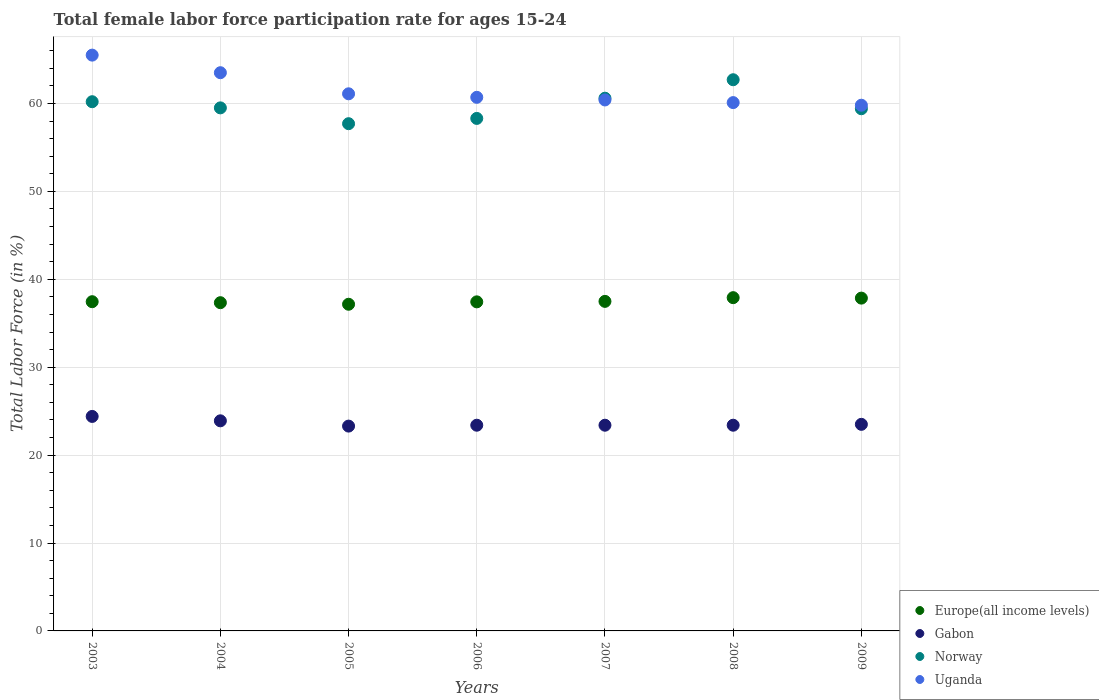How many different coloured dotlines are there?
Make the answer very short. 4. Is the number of dotlines equal to the number of legend labels?
Offer a terse response. Yes. What is the female labor force participation rate in Uganda in 2005?
Offer a terse response. 61.1. Across all years, what is the maximum female labor force participation rate in Europe(all income levels)?
Provide a succinct answer. 37.91. Across all years, what is the minimum female labor force participation rate in Europe(all income levels)?
Offer a very short reply. 37.16. In which year was the female labor force participation rate in Norway maximum?
Give a very brief answer. 2008. In which year was the female labor force participation rate in Europe(all income levels) minimum?
Offer a very short reply. 2005. What is the total female labor force participation rate in Europe(all income levels) in the graph?
Offer a terse response. 262.64. What is the difference between the female labor force participation rate in Gabon in 2005 and that in 2007?
Provide a short and direct response. -0.1. What is the difference between the female labor force participation rate in Norway in 2008 and the female labor force participation rate in Uganda in 2009?
Offer a terse response. 2.9. What is the average female labor force participation rate in Norway per year?
Offer a terse response. 59.77. In the year 2009, what is the difference between the female labor force participation rate in Norway and female labor force participation rate in Gabon?
Give a very brief answer. 35.9. What is the ratio of the female labor force participation rate in Gabon in 2003 to that in 2008?
Your answer should be compact. 1.04. Is the difference between the female labor force participation rate in Norway in 2006 and 2009 greater than the difference between the female labor force participation rate in Gabon in 2006 and 2009?
Your answer should be very brief. No. What is the difference between the highest and the lowest female labor force participation rate in Europe(all income levels)?
Your answer should be compact. 0.75. Is it the case that in every year, the sum of the female labor force participation rate in Europe(all income levels) and female labor force participation rate in Gabon  is greater than the sum of female labor force participation rate in Norway and female labor force participation rate in Uganda?
Provide a short and direct response. Yes. Is it the case that in every year, the sum of the female labor force participation rate in Norway and female labor force participation rate in Uganda  is greater than the female labor force participation rate in Europe(all income levels)?
Provide a short and direct response. Yes. Does the female labor force participation rate in Gabon monotonically increase over the years?
Provide a short and direct response. No. Is the female labor force participation rate in Gabon strictly greater than the female labor force participation rate in Uganda over the years?
Provide a succinct answer. No. Is the female labor force participation rate in Uganda strictly less than the female labor force participation rate in Norway over the years?
Your answer should be very brief. No. How many years are there in the graph?
Make the answer very short. 7. What is the difference between two consecutive major ticks on the Y-axis?
Offer a terse response. 10. Are the values on the major ticks of Y-axis written in scientific E-notation?
Offer a terse response. No. Does the graph contain any zero values?
Give a very brief answer. No. How many legend labels are there?
Your answer should be very brief. 4. What is the title of the graph?
Provide a short and direct response. Total female labor force participation rate for ages 15-24. What is the Total Labor Force (in %) in Europe(all income levels) in 2003?
Offer a very short reply. 37.45. What is the Total Labor Force (in %) of Gabon in 2003?
Your answer should be very brief. 24.4. What is the Total Labor Force (in %) of Norway in 2003?
Keep it short and to the point. 60.2. What is the Total Labor Force (in %) of Uganda in 2003?
Provide a short and direct response. 65.5. What is the Total Labor Force (in %) in Europe(all income levels) in 2004?
Offer a terse response. 37.34. What is the Total Labor Force (in %) in Gabon in 2004?
Keep it short and to the point. 23.9. What is the Total Labor Force (in %) in Norway in 2004?
Make the answer very short. 59.5. What is the Total Labor Force (in %) in Uganda in 2004?
Your answer should be compact. 63.5. What is the Total Labor Force (in %) in Europe(all income levels) in 2005?
Provide a succinct answer. 37.16. What is the Total Labor Force (in %) of Gabon in 2005?
Your response must be concise. 23.3. What is the Total Labor Force (in %) in Norway in 2005?
Ensure brevity in your answer.  57.7. What is the Total Labor Force (in %) of Uganda in 2005?
Your response must be concise. 61.1. What is the Total Labor Force (in %) in Europe(all income levels) in 2006?
Your answer should be very brief. 37.43. What is the Total Labor Force (in %) in Gabon in 2006?
Make the answer very short. 23.4. What is the Total Labor Force (in %) of Norway in 2006?
Keep it short and to the point. 58.3. What is the Total Labor Force (in %) of Uganda in 2006?
Keep it short and to the point. 60.7. What is the Total Labor Force (in %) of Europe(all income levels) in 2007?
Provide a short and direct response. 37.49. What is the Total Labor Force (in %) of Gabon in 2007?
Make the answer very short. 23.4. What is the Total Labor Force (in %) in Norway in 2007?
Your answer should be very brief. 60.6. What is the Total Labor Force (in %) of Uganda in 2007?
Provide a short and direct response. 60.4. What is the Total Labor Force (in %) of Europe(all income levels) in 2008?
Make the answer very short. 37.91. What is the Total Labor Force (in %) in Gabon in 2008?
Your response must be concise. 23.4. What is the Total Labor Force (in %) of Norway in 2008?
Provide a succinct answer. 62.7. What is the Total Labor Force (in %) in Uganda in 2008?
Your answer should be compact. 60.1. What is the Total Labor Force (in %) of Europe(all income levels) in 2009?
Ensure brevity in your answer.  37.86. What is the Total Labor Force (in %) of Norway in 2009?
Your answer should be compact. 59.4. What is the Total Labor Force (in %) in Uganda in 2009?
Make the answer very short. 59.8. Across all years, what is the maximum Total Labor Force (in %) in Europe(all income levels)?
Provide a short and direct response. 37.91. Across all years, what is the maximum Total Labor Force (in %) of Gabon?
Your answer should be compact. 24.4. Across all years, what is the maximum Total Labor Force (in %) of Norway?
Your answer should be very brief. 62.7. Across all years, what is the maximum Total Labor Force (in %) in Uganda?
Your response must be concise. 65.5. Across all years, what is the minimum Total Labor Force (in %) in Europe(all income levels)?
Ensure brevity in your answer.  37.16. Across all years, what is the minimum Total Labor Force (in %) of Gabon?
Offer a very short reply. 23.3. Across all years, what is the minimum Total Labor Force (in %) of Norway?
Give a very brief answer. 57.7. Across all years, what is the minimum Total Labor Force (in %) in Uganda?
Keep it short and to the point. 59.8. What is the total Total Labor Force (in %) of Europe(all income levels) in the graph?
Offer a terse response. 262.64. What is the total Total Labor Force (in %) of Gabon in the graph?
Provide a short and direct response. 165.3. What is the total Total Labor Force (in %) of Norway in the graph?
Provide a succinct answer. 418.4. What is the total Total Labor Force (in %) of Uganda in the graph?
Provide a succinct answer. 431.1. What is the difference between the Total Labor Force (in %) of Europe(all income levels) in 2003 and that in 2004?
Your answer should be very brief. 0.11. What is the difference between the Total Labor Force (in %) in Gabon in 2003 and that in 2004?
Ensure brevity in your answer.  0.5. What is the difference between the Total Labor Force (in %) in Uganda in 2003 and that in 2004?
Provide a succinct answer. 2. What is the difference between the Total Labor Force (in %) in Europe(all income levels) in 2003 and that in 2005?
Your answer should be compact. 0.29. What is the difference between the Total Labor Force (in %) of Norway in 2003 and that in 2005?
Provide a succinct answer. 2.5. What is the difference between the Total Labor Force (in %) of Europe(all income levels) in 2003 and that in 2006?
Your answer should be compact. 0.02. What is the difference between the Total Labor Force (in %) in Gabon in 2003 and that in 2006?
Offer a very short reply. 1. What is the difference between the Total Labor Force (in %) of Uganda in 2003 and that in 2006?
Your answer should be compact. 4.8. What is the difference between the Total Labor Force (in %) of Europe(all income levels) in 2003 and that in 2007?
Keep it short and to the point. -0.04. What is the difference between the Total Labor Force (in %) of Gabon in 2003 and that in 2007?
Offer a terse response. 1. What is the difference between the Total Labor Force (in %) in Norway in 2003 and that in 2007?
Make the answer very short. -0.4. What is the difference between the Total Labor Force (in %) in Uganda in 2003 and that in 2007?
Offer a terse response. 5.1. What is the difference between the Total Labor Force (in %) of Europe(all income levels) in 2003 and that in 2008?
Offer a very short reply. -0.46. What is the difference between the Total Labor Force (in %) in Europe(all income levels) in 2003 and that in 2009?
Keep it short and to the point. -0.41. What is the difference between the Total Labor Force (in %) of Europe(all income levels) in 2004 and that in 2005?
Make the answer very short. 0.18. What is the difference between the Total Labor Force (in %) of Uganda in 2004 and that in 2005?
Provide a succinct answer. 2.4. What is the difference between the Total Labor Force (in %) in Europe(all income levels) in 2004 and that in 2006?
Offer a terse response. -0.09. What is the difference between the Total Labor Force (in %) of Europe(all income levels) in 2004 and that in 2007?
Provide a succinct answer. -0.15. What is the difference between the Total Labor Force (in %) of Europe(all income levels) in 2004 and that in 2008?
Ensure brevity in your answer.  -0.57. What is the difference between the Total Labor Force (in %) in Gabon in 2004 and that in 2008?
Your answer should be compact. 0.5. What is the difference between the Total Labor Force (in %) of Norway in 2004 and that in 2008?
Your response must be concise. -3.2. What is the difference between the Total Labor Force (in %) of Uganda in 2004 and that in 2008?
Offer a terse response. 3.4. What is the difference between the Total Labor Force (in %) of Europe(all income levels) in 2004 and that in 2009?
Offer a terse response. -0.52. What is the difference between the Total Labor Force (in %) of Norway in 2004 and that in 2009?
Keep it short and to the point. 0.1. What is the difference between the Total Labor Force (in %) of Europe(all income levels) in 2005 and that in 2006?
Offer a terse response. -0.27. What is the difference between the Total Labor Force (in %) of Norway in 2005 and that in 2006?
Ensure brevity in your answer.  -0.6. What is the difference between the Total Labor Force (in %) of Uganda in 2005 and that in 2006?
Make the answer very short. 0.4. What is the difference between the Total Labor Force (in %) in Europe(all income levels) in 2005 and that in 2007?
Give a very brief answer. -0.33. What is the difference between the Total Labor Force (in %) of Norway in 2005 and that in 2007?
Make the answer very short. -2.9. What is the difference between the Total Labor Force (in %) of Uganda in 2005 and that in 2007?
Offer a very short reply. 0.7. What is the difference between the Total Labor Force (in %) of Europe(all income levels) in 2005 and that in 2008?
Provide a succinct answer. -0.75. What is the difference between the Total Labor Force (in %) of Gabon in 2005 and that in 2008?
Make the answer very short. -0.1. What is the difference between the Total Labor Force (in %) in Uganda in 2005 and that in 2008?
Offer a terse response. 1. What is the difference between the Total Labor Force (in %) of Europe(all income levels) in 2005 and that in 2009?
Make the answer very short. -0.7. What is the difference between the Total Labor Force (in %) in Norway in 2005 and that in 2009?
Provide a short and direct response. -1.7. What is the difference between the Total Labor Force (in %) in Europe(all income levels) in 2006 and that in 2007?
Make the answer very short. -0.05. What is the difference between the Total Labor Force (in %) in Gabon in 2006 and that in 2007?
Offer a terse response. 0. What is the difference between the Total Labor Force (in %) of Norway in 2006 and that in 2007?
Give a very brief answer. -2.3. What is the difference between the Total Labor Force (in %) in Europe(all income levels) in 2006 and that in 2008?
Make the answer very short. -0.48. What is the difference between the Total Labor Force (in %) of Norway in 2006 and that in 2008?
Provide a succinct answer. -4.4. What is the difference between the Total Labor Force (in %) of Europe(all income levels) in 2006 and that in 2009?
Offer a very short reply. -0.43. What is the difference between the Total Labor Force (in %) of Gabon in 2006 and that in 2009?
Ensure brevity in your answer.  -0.1. What is the difference between the Total Labor Force (in %) of Europe(all income levels) in 2007 and that in 2008?
Keep it short and to the point. -0.42. What is the difference between the Total Labor Force (in %) in Uganda in 2007 and that in 2008?
Offer a very short reply. 0.3. What is the difference between the Total Labor Force (in %) of Europe(all income levels) in 2007 and that in 2009?
Your answer should be compact. -0.37. What is the difference between the Total Labor Force (in %) of Gabon in 2007 and that in 2009?
Provide a succinct answer. -0.1. What is the difference between the Total Labor Force (in %) of Norway in 2007 and that in 2009?
Give a very brief answer. 1.2. What is the difference between the Total Labor Force (in %) in Europe(all income levels) in 2008 and that in 2009?
Your answer should be compact. 0.05. What is the difference between the Total Labor Force (in %) in Norway in 2008 and that in 2009?
Make the answer very short. 3.3. What is the difference between the Total Labor Force (in %) of Uganda in 2008 and that in 2009?
Your response must be concise. 0.3. What is the difference between the Total Labor Force (in %) in Europe(all income levels) in 2003 and the Total Labor Force (in %) in Gabon in 2004?
Offer a terse response. 13.55. What is the difference between the Total Labor Force (in %) in Europe(all income levels) in 2003 and the Total Labor Force (in %) in Norway in 2004?
Make the answer very short. -22.05. What is the difference between the Total Labor Force (in %) in Europe(all income levels) in 2003 and the Total Labor Force (in %) in Uganda in 2004?
Provide a short and direct response. -26.05. What is the difference between the Total Labor Force (in %) of Gabon in 2003 and the Total Labor Force (in %) of Norway in 2004?
Keep it short and to the point. -35.1. What is the difference between the Total Labor Force (in %) in Gabon in 2003 and the Total Labor Force (in %) in Uganda in 2004?
Offer a terse response. -39.1. What is the difference between the Total Labor Force (in %) in Norway in 2003 and the Total Labor Force (in %) in Uganda in 2004?
Provide a succinct answer. -3.3. What is the difference between the Total Labor Force (in %) of Europe(all income levels) in 2003 and the Total Labor Force (in %) of Gabon in 2005?
Provide a short and direct response. 14.15. What is the difference between the Total Labor Force (in %) in Europe(all income levels) in 2003 and the Total Labor Force (in %) in Norway in 2005?
Your answer should be compact. -20.25. What is the difference between the Total Labor Force (in %) of Europe(all income levels) in 2003 and the Total Labor Force (in %) of Uganda in 2005?
Offer a terse response. -23.65. What is the difference between the Total Labor Force (in %) in Gabon in 2003 and the Total Labor Force (in %) in Norway in 2005?
Provide a succinct answer. -33.3. What is the difference between the Total Labor Force (in %) in Gabon in 2003 and the Total Labor Force (in %) in Uganda in 2005?
Offer a terse response. -36.7. What is the difference between the Total Labor Force (in %) in Europe(all income levels) in 2003 and the Total Labor Force (in %) in Gabon in 2006?
Offer a very short reply. 14.05. What is the difference between the Total Labor Force (in %) of Europe(all income levels) in 2003 and the Total Labor Force (in %) of Norway in 2006?
Provide a short and direct response. -20.85. What is the difference between the Total Labor Force (in %) in Europe(all income levels) in 2003 and the Total Labor Force (in %) in Uganda in 2006?
Provide a succinct answer. -23.25. What is the difference between the Total Labor Force (in %) in Gabon in 2003 and the Total Labor Force (in %) in Norway in 2006?
Ensure brevity in your answer.  -33.9. What is the difference between the Total Labor Force (in %) of Gabon in 2003 and the Total Labor Force (in %) of Uganda in 2006?
Your response must be concise. -36.3. What is the difference between the Total Labor Force (in %) of Norway in 2003 and the Total Labor Force (in %) of Uganda in 2006?
Your answer should be very brief. -0.5. What is the difference between the Total Labor Force (in %) of Europe(all income levels) in 2003 and the Total Labor Force (in %) of Gabon in 2007?
Ensure brevity in your answer.  14.05. What is the difference between the Total Labor Force (in %) of Europe(all income levels) in 2003 and the Total Labor Force (in %) of Norway in 2007?
Offer a terse response. -23.15. What is the difference between the Total Labor Force (in %) in Europe(all income levels) in 2003 and the Total Labor Force (in %) in Uganda in 2007?
Offer a terse response. -22.95. What is the difference between the Total Labor Force (in %) of Gabon in 2003 and the Total Labor Force (in %) of Norway in 2007?
Make the answer very short. -36.2. What is the difference between the Total Labor Force (in %) in Gabon in 2003 and the Total Labor Force (in %) in Uganda in 2007?
Your answer should be compact. -36. What is the difference between the Total Labor Force (in %) of Europe(all income levels) in 2003 and the Total Labor Force (in %) of Gabon in 2008?
Provide a succinct answer. 14.05. What is the difference between the Total Labor Force (in %) in Europe(all income levels) in 2003 and the Total Labor Force (in %) in Norway in 2008?
Your answer should be compact. -25.25. What is the difference between the Total Labor Force (in %) in Europe(all income levels) in 2003 and the Total Labor Force (in %) in Uganda in 2008?
Your answer should be very brief. -22.65. What is the difference between the Total Labor Force (in %) in Gabon in 2003 and the Total Labor Force (in %) in Norway in 2008?
Provide a succinct answer. -38.3. What is the difference between the Total Labor Force (in %) in Gabon in 2003 and the Total Labor Force (in %) in Uganda in 2008?
Provide a short and direct response. -35.7. What is the difference between the Total Labor Force (in %) in Europe(all income levels) in 2003 and the Total Labor Force (in %) in Gabon in 2009?
Provide a succinct answer. 13.95. What is the difference between the Total Labor Force (in %) of Europe(all income levels) in 2003 and the Total Labor Force (in %) of Norway in 2009?
Ensure brevity in your answer.  -21.95. What is the difference between the Total Labor Force (in %) of Europe(all income levels) in 2003 and the Total Labor Force (in %) of Uganda in 2009?
Offer a terse response. -22.35. What is the difference between the Total Labor Force (in %) in Gabon in 2003 and the Total Labor Force (in %) in Norway in 2009?
Your answer should be compact. -35. What is the difference between the Total Labor Force (in %) in Gabon in 2003 and the Total Labor Force (in %) in Uganda in 2009?
Provide a short and direct response. -35.4. What is the difference between the Total Labor Force (in %) in Norway in 2003 and the Total Labor Force (in %) in Uganda in 2009?
Offer a very short reply. 0.4. What is the difference between the Total Labor Force (in %) of Europe(all income levels) in 2004 and the Total Labor Force (in %) of Gabon in 2005?
Your answer should be compact. 14.04. What is the difference between the Total Labor Force (in %) in Europe(all income levels) in 2004 and the Total Labor Force (in %) in Norway in 2005?
Offer a terse response. -20.36. What is the difference between the Total Labor Force (in %) of Europe(all income levels) in 2004 and the Total Labor Force (in %) of Uganda in 2005?
Ensure brevity in your answer.  -23.76. What is the difference between the Total Labor Force (in %) of Gabon in 2004 and the Total Labor Force (in %) of Norway in 2005?
Your answer should be compact. -33.8. What is the difference between the Total Labor Force (in %) in Gabon in 2004 and the Total Labor Force (in %) in Uganda in 2005?
Offer a terse response. -37.2. What is the difference between the Total Labor Force (in %) of Norway in 2004 and the Total Labor Force (in %) of Uganda in 2005?
Your answer should be very brief. -1.6. What is the difference between the Total Labor Force (in %) in Europe(all income levels) in 2004 and the Total Labor Force (in %) in Gabon in 2006?
Offer a very short reply. 13.94. What is the difference between the Total Labor Force (in %) of Europe(all income levels) in 2004 and the Total Labor Force (in %) of Norway in 2006?
Offer a very short reply. -20.96. What is the difference between the Total Labor Force (in %) in Europe(all income levels) in 2004 and the Total Labor Force (in %) in Uganda in 2006?
Your response must be concise. -23.36. What is the difference between the Total Labor Force (in %) of Gabon in 2004 and the Total Labor Force (in %) of Norway in 2006?
Provide a short and direct response. -34.4. What is the difference between the Total Labor Force (in %) of Gabon in 2004 and the Total Labor Force (in %) of Uganda in 2006?
Your answer should be compact. -36.8. What is the difference between the Total Labor Force (in %) in Europe(all income levels) in 2004 and the Total Labor Force (in %) in Gabon in 2007?
Offer a terse response. 13.94. What is the difference between the Total Labor Force (in %) of Europe(all income levels) in 2004 and the Total Labor Force (in %) of Norway in 2007?
Provide a succinct answer. -23.26. What is the difference between the Total Labor Force (in %) of Europe(all income levels) in 2004 and the Total Labor Force (in %) of Uganda in 2007?
Provide a short and direct response. -23.06. What is the difference between the Total Labor Force (in %) in Gabon in 2004 and the Total Labor Force (in %) in Norway in 2007?
Keep it short and to the point. -36.7. What is the difference between the Total Labor Force (in %) in Gabon in 2004 and the Total Labor Force (in %) in Uganda in 2007?
Your answer should be very brief. -36.5. What is the difference between the Total Labor Force (in %) of Europe(all income levels) in 2004 and the Total Labor Force (in %) of Gabon in 2008?
Offer a very short reply. 13.94. What is the difference between the Total Labor Force (in %) in Europe(all income levels) in 2004 and the Total Labor Force (in %) in Norway in 2008?
Give a very brief answer. -25.36. What is the difference between the Total Labor Force (in %) in Europe(all income levels) in 2004 and the Total Labor Force (in %) in Uganda in 2008?
Your response must be concise. -22.76. What is the difference between the Total Labor Force (in %) in Gabon in 2004 and the Total Labor Force (in %) in Norway in 2008?
Your answer should be compact. -38.8. What is the difference between the Total Labor Force (in %) of Gabon in 2004 and the Total Labor Force (in %) of Uganda in 2008?
Keep it short and to the point. -36.2. What is the difference between the Total Labor Force (in %) in Norway in 2004 and the Total Labor Force (in %) in Uganda in 2008?
Keep it short and to the point. -0.6. What is the difference between the Total Labor Force (in %) of Europe(all income levels) in 2004 and the Total Labor Force (in %) of Gabon in 2009?
Ensure brevity in your answer.  13.84. What is the difference between the Total Labor Force (in %) of Europe(all income levels) in 2004 and the Total Labor Force (in %) of Norway in 2009?
Offer a very short reply. -22.06. What is the difference between the Total Labor Force (in %) of Europe(all income levels) in 2004 and the Total Labor Force (in %) of Uganda in 2009?
Offer a very short reply. -22.46. What is the difference between the Total Labor Force (in %) in Gabon in 2004 and the Total Labor Force (in %) in Norway in 2009?
Offer a very short reply. -35.5. What is the difference between the Total Labor Force (in %) in Gabon in 2004 and the Total Labor Force (in %) in Uganda in 2009?
Give a very brief answer. -35.9. What is the difference between the Total Labor Force (in %) of Norway in 2004 and the Total Labor Force (in %) of Uganda in 2009?
Provide a succinct answer. -0.3. What is the difference between the Total Labor Force (in %) of Europe(all income levels) in 2005 and the Total Labor Force (in %) of Gabon in 2006?
Offer a very short reply. 13.76. What is the difference between the Total Labor Force (in %) of Europe(all income levels) in 2005 and the Total Labor Force (in %) of Norway in 2006?
Make the answer very short. -21.14. What is the difference between the Total Labor Force (in %) in Europe(all income levels) in 2005 and the Total Labor Force (in %) in Uganda in 2006?
Keep it short and to the point. -23.54. What is the difference between the Total Labor Force (in %) of Gabon in 2005 and the Total Labor Force (in %) of Norway in 2006?
Provide a succinct answer. -35. What is the difference between the Total Labor Force (in %) in Gabon in 2005 and the Total Labor Force (in %) in Uganda in 2006?
Offer a terse response. -37.4. What is the difference between the Total Labor Force (in %) of Europe(all income levels) in 2005 and the Total Labor Force (in %) of Gabon in 2007?
Provide a short and direct response. 13.76. What is the difference between the Total Labor Force (in %) of Europe(all income levels) in 2005 and the Total Labor Force (in %) of Norway in 2007?
Your response must be concise. -23.44. What is the difference between the Total Labor Force (in %) of Europe(all income levels) in 2005 and the Total Labor Force (in %) of Uganda in 2007?
Make the answer very short. -23.24. What is the difference between the Total Labor Force (in %) of Gabon in 2005 and the Total Labor Force (in %) of Norway in 2007?
Provide a short and direct response. -37.3. What is the difference between the Total Labor Force (in %) of Gabon in 2005 and the Total Labor Force (in %) of Uganda in 2007?
Ensure brevity in your answer.  -37.1. What is the difference between the Total Labor Force (in %) of Europe(all income levels) in 2005 and the Total Labor Force (in %) of Gabon in 2008?
Your response must be concise. 13.76. What is the difference between the Total Labor Force (in %) of Europe(all income levels) in 2005 and the Total Labor Force (in %) of Norway in 2008?
Give a very brief answer. -25.54. What is the difference between the Total Labor Force (in %) of Europe(all income levels) in 2005 and the Total Labor Force (in %) of Uganda in 2008?
Make the answer very short. -22.94. What is the difference between the Total Labor Force (in %) in Gabon in 2005 and the Total Labor Force (in %) in Norway in 2008?
Your answer should be compact. -39.4. What is the difference between the Total Labor Force (in %) in Gabon in 2005 and the Total Labor Force (in %) in Uganda in 2008?
Provide a succinct answer. -36.8. What is the difference between the Total Labor Force (in %) of Europe(all income levels) in 2005 and the Total Labor Force (in %) of Gabon in 2009?
Your answer should be compact. 13.66. What is the difference between the Total Labor Force (in %) of Europe(all income levels) in 2005 and the Total Labor Force (in %) of Norway in 2009?
Give a very brief answer. -22.24. What is the difference between the Total Labor Force (in %) of Europe(all income levels) in 2005 and the Total Labor Force (in %) of Uganda in 2009?
Provide a succinct answer. -22.64. What is the difference between the Total Labor Force (in %) in Gabon in 2005 and the Total Labor Force (in %) in Norway in 2009?
Give a very brief answer. -36.1. What is the difference between the Total Labor Force (in %) in Gabon in 2005 and the Total Labor Force (in %) in Uganda in 2009?
Ensure brevity in your answer.  -36.5. What is the difference between the Total Labor Force (in %) of Norway in 2005 and the Total Labor Force (in %) of Uganda in 2009?
Make the answer very short. -2.1. What is the difference between the Total Labor Force (in %) in Europe(all income levels) in 2006 and the Total Labor Force (in %) in Gabon in 2007?
Offer a terse response. 14.03. What is the difference between the Total Labor Force (in %) in Europe(all income levels) in 2006 and the Total Labor Force (in %) in Norway in 2007?
Provide a succinct answer. -23.17. What is the difference between the Total Labor Force (in %) in Europe(all income levels) in 2006 and the Total Labor Force (in %) in Uganda in 2007?
Make the answer very short. -22.97. What is the difference between the Total Labor Force (in %) of Gabon in 2006 and the Total Labor Force (in %) of Norway in 2007?
Give a very brief answer. -37.2. What is the difference between the Total Labor Force (in %) of Gabon in 2006 and the Total Labor Force (in %) of Uganda in 2007?
Keep it short and to the point. -37. What is the difference between the Total Labor Force (in %) of Norway in 2006 and the Total Labor Force (in %) of Uganda in 2007?
Offer a very short reply. -2.1. What is the difference between the Total Labor Force (in %) of Europe(all income levels) in 2006 and the Total Labor Force (in %) of Gabon in 2008?
Offer a very short reply. 14.03. What is the difference between the Total Labor Force (in %) of Europe(all income levels) in 2006 and the Total Labor Force (in %) of Norway in 2008?
Keep it short and to the point. -25.27. What is the difference between the Total Labor Force (in %) in Europe(all income levels) in 2006 and the Total Labor Force (in %) in Uganda in 2008?
Offer a terse response. -22.67. What is the difference between the Total Labor Force (in %) of Gabon in 2006 and the Total Labor Force (in %) of Norway in 2008?
Ensure brevity in your answer.  -39.3. What is the difference between the Total Labor Force (in %) in Gabon in 2006 and the Total Labor Force (in %) in Uganda in 2008?
Ensure brevity in your answer.  -36.7. What is the difference between the Total Labor Force (in %) of Norway in 2006 and the Total Labor Force (in %) of Uganda in 2008?
Your response must be concise. -1.8. What is the difference between the Total Labor Force (in %) of Europe(all income levels) in 2006 and the Total Labor Force (in %) of Gabon in 2009?
Make the answer very short. 13.93. What is the difference between the Total Labor Force (in %) in Europe(all income levels) in 2006 and the Total Labor Force (in %) in Norway in 2009?
Give a very brief answer. -21.97. What is the difference between the Total Labor Force (in %) of Europe(all income levels) in 2006 and the Total Labor Force (in %) of Uganda in 2009?
Ensure brevity in your answer.  -22.37. What is the difference between the Total Labor Force (in %) in Gabon in 2006 and the Total Labor Force (in %) in Norway in 2009?
Provide a succinct answer. -36. What is the difference between the Total Labor Force (in %) of Gabon in 2006 and the Total Labor Force (in %) of Uganda in 2009?
Make the answer very short. -36.4. What is the difference between the Total Labor Force (in %) in Europe(all income levels) in 2007 and the Total Labor Force (in %) in Gabon in 2008?
Give a very brief answer. 14.09. What is the difference between the Total Labor Force (in %) of Europe(all income levels) in 2007 and the Total Labor Force (in %) of Norway in 2008?
Provide a succinct answer. -25.21. What is the difference between the Total Labor Force (in %) of Europe(all income levels) in 2007 and the Total Labor Force (in %) of Uganda in 2008?
Provide a short and direct response. -22.61. What is the difference between the Total Labor Force (in %) of Gabon in 2007 and the Total Labor Force (in %) of Norway in 2008?
Offer a terse response. -39.3. What is the difference between the Total Labor Force (in %) in Gabon in 2007 and the Total Labor Force (in %) in Uganda in 2008?
Provide a succinct answer. -36.7. What is the difference between the Total Labor Force (in %) in Europe(all income levels) in 2007 and the Total Labor Force (in %) in Gabon in 2009?
Offer a terse response. 13.99. What is the difference between the Total Labor Force (in %) in Europe(all income levels) in 2007 and the Total Labor Force (in %) in Norway in 2009?
Provide a succinct answer. -21.91. What is the difference between the Total Labor Force (in %) in Europe(all income levels) in 2007 and the Total Labor Force (in %) in Uganda in 2009?
Offer a very short reply. -22.31. What is the difference between the Total Labor Force (in %) in Gabon in 2007 and the Total Labor Force (in %) in Norway in 2009?
Provide a succinct answer. -36. What is the difference between the Total Labor Force (in %) in Gabon in 2007 and the Total Labor Force (in %) in Uganda in 2009?
Offer a very short reply. -36.4. What is the difference between the Total Labor Force (in %) of Norway in 2007 and the Total Labor Force (in %) of Uganda in 2009?
Make the answer very short. 0.8. What is the difference between the Total Labor Force (in %) in Europe(all income levels) in 2008 and the Total Labor Force (in %) in Gabon in 2009?
Offer a very short reply. 14.41. What is the difference between the Total Labor Force (in %) in Europe(all income levels) in 2008 and the Total Labor Force (in %) in Norway in 2009?
Make the answer very short. -21.49. What is the difference between the Total Labor Force (in %) in Europe(all income levels) in 2008 and the Total Labor Force (in %) in Uganda in 2009?
Your answer should be very brief. -21.89. What is the difference between the Total Labor Force (in %) in Gabon in 2008 and the Total Labor Force (in %) in Norway in 2009?
Offer a very short reply. -36. What is the difference between the Total Labor Force (in %) of Gabon in 2008 and the Total Labor Force (in %) of Uganda in 2009?
Provide a short and direct response. -36.4. What is the difference between the Total Labor Force (in %) in Norway in 2008 and the Total Labor Force (in %) in Uganda in 2009?
Make the answer very short. 2.9. What is the average Total Labor Force (in %) of Europe(all income levels) per year?
Make the answer very short. 37.52. What is the average Total Labor Force (in %) of Gabon per year?
Provide a succinct answer. 23.61. What is the average Total Labor Force (in %) of Norway per year?
Give a very brief answer. 59.77. What is the average Total Labor Force (in %) in Uganda per year?
Keep it short and to the point. 61.59. In the year 2003, what is the difference between the Total Labor Force (in %) of Europe(all income levels) and Total Labor Force (in %) of Gabon?
Make the answer very short. 13.05. In the year 2003, what is the difference between the Total Labor Force (in %) of Europe(all income levels) and Total Labor Force (in %) of Norway?
Give a very brief answer. -22.75. In the year 2003, what is the difference between the Total Labor Force (in %) in Europe(all income levels) and Total Labor Force (in %) in Uganda?
Your response must be concise. -28.05. In the year 2003, what is the difference between the Total Labor Force (in %) in Gabon and Total Labor Force (in %) in Norway?
Make the answer very short. -35.8. In the year 2003, what is the difference between the Total Labor Force (in %) of Gabon and Total Labor Force (in %) of Uganda?
Provide a succinct answer. -41.1. In the year 2004, what is the difference between the Total Labor Force (in %) of Europe(all income levels) and Total Labor Force (in %) of Gabon?
Your answer should be compact. 13.44. In the year 2004, what is the difference between the Total Labor Force (in %) in Europe(all income levels) and Total Labor Force (in %) in Norway?
Your answer should be very brief. -22.16. In the year 2004, what is the difference between the Total Labor Force (in %) of Europe(all income levels) and Total Labor Force (in %) of Uganda?
Make the answer very short. -26.16. In the year 2004, what is the difference between the Total Labor Force (in %) in Gabon and Total Labor Force (in %) in Norway?
Ensure brevity in your answer.  -35.6. In the year 2004, what is the difference between the Total Labor Force (in %) of Gabon and Total Labor Force (in %) of Uganda?
Provide a succinct answer. -39.6. In the year 2005, what is the difference between the Total Labor Force (in %) in Europe(all income levels) and Total Labor Force (in %) in Gabon?
Give a very brief answer. 13.86. In the year 2005, what is the difference between the Total Labor Force (in %) of Europe(all income levels) and Total Labor Force (in %) of Norway?
Keep it short and to the point. -20.54. In the year 2005, what is the difference between the Total Labor Force (in %) in Europe(all income levels) and Total Labor Force (in %) in Uganda?
Keep it short and to the point. -23.94. In the year 2005, what is the difference between the Total Labor Force (in %) in Gabon and Total Labor Force (in %) in Norway?
Your answer should be compact. -34.4. In the year 2005, what is the difference between the Total Labor Force (in %) in Gabon and Total Labor Force (in %) in Uganda?
Keep it short and to the point. -37.8. In the year 2006, what is the difference between the Total Labor Force (in %) of Europe(all income levels) and Total Labor Force (in %) of Gabon?
Your answer should be very brief. 14.03. In the year 2006, what is the difference between the Total Labor Force (in %) of Europe(all income levels) and Total Labor Force (in %) of Norway?
Provide a succinct answer. -20.87. In the year 2006, what is the difference between the Total Labor Force (in %) in Europe(all income levels) and Total Labor Force (in %) in Uganda?
Give a very brief answer. -23.27. In the year 2006, what is the difference between the Total Labor Force (in %) of Gabon and Total Labor Force (in %) of Norway?
Ensure brevity in your answer.  -34.9. In the year 2006, what is the difference between the Total Labor Force (in %) of Gabon and Total Labor Force (in %) of Uganda?
Give a very brief answer. -37.3. In the year 2007, what is the difference between the Total Labor Force (in %) in Europe(all income levels) and Total Labor Force (in %) in Gabon?
Ensure brevity in your answer.  14.09. In the year 2007, what is the difference between the Total Labor Force (in %) in Europe(all income levels) and Total Labor Force (in %) in Norway?
Ensure brevity in your answer.  -23.11. In the year 2007, what is the difference between the Total Labor Force (in %) in Europe(all income levels) and Total Labor Force (in %) in Uganda?
Your response must be concise. -22.91. In the year 2007, what is the difference between the Total Labor Force (in %) in Gabon and Total Labor Force (in %) in Norway?
Provide a succinct answer. -37.2. In the year 2007, what is the difference between the Total Labor Force (in %) in Gabon and Total Labor Force (in %) in Uganda?
Make the answer very short. -37. In the year 2008, what is the difference between the Total Labor Force (in %) in Europe(all income levels) and Total Labor Force (in %) in Gabon?
Offer a very short reply. 14.51. In the year 2008, what is the difference between the Total Labor Force (in %) of Europe(all income levels) and Total Labor Force (in %) of Norway?
Provide a short and direct response. -24.79. In the year 2008, what is the difference between the Total Labor Force (in %) in Europe(all income levels) and Total Labor Force (in %) in Uganda?
Offer a terse response. -22.19. In the year 2008, what is the difference between the Total Labor Force (in %) in Gabon and Total Labor Force (in %) in Norway?
Offer a terse response. -39.3. In the year 2008, what is the difference between the Total Labor Force (in %) of Gabon and Total Labor Force (in %) of Uganda?
Your response must be concise. -36.7. In the year 2009, what is the difference between the Total Labor Force (in %) in Europe(all income levels) and Total Labor Force (in %) in Gabon?
Your answer should be compact. 14.36. In the year 2009, what is the difference between the Total Labor Force (in %) in Europe(all income levels) and Total Labor Force (in %) in Norway?
Your answer should be very brief. -21.54. In the year 2009, what is the difference between the Total Labor Force (in %) of Europe(all income levels) and Total Labor Force (in %) of Uganda?
Your answer should be compact. -21.94. In the year 2009, what is the difference between the Total Labor Force (in %) in Gabon and Total Labor Force (in %) in Norway?
Ensure brevity in your answer.  -35.9. In the year 2009, what is the difference between the Total Labor Force (in %) in Gabon and Total Labor Force (in %) in Uganda?
Your answer should be very brief. -36.3. What is the ratio of the Total Labor Force (in %) in Gabon in 2003 to that in 2004?
Make the answer very short. 1.02. What is the ratio of the Total Labor Force (in %) in Norway in 2003 to that in 2004?
Your answer should be very brief. 1.01. What is the ratio of the Total Labor Force (in %) in Uganda in 2003 to that in 2004?
Provide a succinct answer. 1.03. What is the ratio of the Total Labor Force (in %) of Europe(all income levels) in 2003 to that in 2005?
Offer a very short reply. 1.01. What is the ratio of the Total Labor Force (in %) in Gabon in 2003 to that in 2005?
Keep it short and to the point. 1.05. What is the ratio of the Total Labor Force (in %) in Norway in 2003 to that in 2005?
Provide a succinct answer. 1.04. What is the ratio of the Total Labor Force (in %) of Uganda in 2003 to that in 2005?
Keep it short and to the point. 1.07. What is the ratio of the Total Labor Force (in %) of Gabon in 2003 to that in 2006?
Offer a terse response. 1.04. What is the ratio of the Total Labor Force (in %) of Norway in 2003 to that in 2006?
Give a very brief answer. 1.03. What is the ratio of the Total Labor Force (in %) in Uganda in 2003 to that in 2006?
Offer a terse response. 1.08. What is the ratio of the Total Labor Force (in %) of Europe(all income levels) in 2003 to that in 2007?
Give a very brief answer. 1. What is the ratio of the Total Labor Force (in %) of Gabon in 2003 to that in 2007?
Make the answer very short. 1.04. What is the ratio of the Total Labor Force (in %) in Uganda in 2003 to that in 2007?
Provide a short and direct response. 1.08. What is the ratio of the Total Labor Force (in %) in Europe(all income levels) in 2003 to that in 2008?
Offer a very short reply. 0.99. What is the ratio of the Total Labor Force (in %) in Gabon in 2003 to that in 2008?
Provide a short and direct response. 1.04. What is the ratio of the Total Labor Force (in %) in Norway in 2003 to that in 2008?
Your response must be concise. 0.96. What is the ratio of the Total Labor Force (in %) of Uganda in 2003 to that in 2008?
Give a very brief answer. 1.09. What is the ratio of the Total Labor Force (in %) of Europe(all income levels) in 2003 to that in 2009?
Give a very brief answer. 0.99. What is the ratio of the Total Labor Force (in %) of Gabon in 2003 to that in 2009?
Offer a very short reply. 1.04. What is the ratio of the Total Labor Force (in %) of Norway in 2003 to that in 2009?
Your response must be concise. 1.01. What is the ratio of the Total Labor Force (in %) in Uganda in 2003 to that in 2009?
Your answer should be compact. 1.1. What is the ratio of the Total Labor Force (in %) of Europe(all income levels) in 2004 to that in 2005?
Your answer should be compact. 1. What is the ratio of the Total Labor Force (in %) in Gabon in 2004 to that in 2005?
Provide a succinct answer. 1.03. What is the ratio of the Total Labor Force (in %) of Norway in 2004 to that in 2005?
Give a very brief answer. 1.03. What is the ratio of the Total Labor Force (in %) in Uganda in 2004 to that in 2005?
Keep it short and to the point. 1.04. What is the ratio of the Total Labor Force (in %) of Gabon in 2004 to that in 2006?
Give a very brief answer. 1.02. What is the ratio of the Total Labor Force (in %) in Norway in 2004 to that in 2006?
Offer a terse response. 1.02. What is the ratio of the Total Labor Force (in %) of Uganda in 2004 to that in 2006?
Make the answer very short. 1.05. What is the ratio of the Total Labor Force (in %) of Europe(all income levels) in 2004 to that in 2007?
Your response must be concise. 1. What is the ratio of the Total Labor Force (in %) in Gabon in 2004 to that in 2007?
Ensure brevity in your answer.  1.02. What is the ratio of the Total Labor Force (in %) of Norway in 2004 to that in 2007?
Provide a succinct answer. 0.98. What is the ratio of the Total Labor Force (in %) in Uganda in 2004 to that in 2007?
Ensure brevity in your answer.  1.05. What is the ratio of the Total Labor Force (in %) of Europe(all income levels) in 2004 to that in 2008?
Give a very brief answer. 0.98. What is the ratio of the Total Labor Force (in %) of Gabon in 2004 to that in 2008?
Your answer should be compact. 1.02. What is the ratio of the Total Labor Force (in %) in Norway in 2004 to that in 2008?
Make the answer very short. 0.95. What is the ratio of the Total Labor Force (in %) of Uganda in 2004 to that in 2008?
Provide a short and direct response. 1.06. What is the ratio of the Total Labor Force (in %) of Europe(all income levels) in 2004 to that in 2009?
Provide a short and direct response. 0.99. What is the ratio of the Total Labor Force (in %) of Gabon in 2004 to that in 2009?
Your answer should be very brief. 1.02. What is the ratio of the Total Labor Force (in %) of Uganda in 2004 to that in 2009?
Your response must be concise. 1.06. What is the ratio of the Total Labor Force (in %) in Gabon in 2005 to that in 2006?
Give a very brief answer. 1. What is the ratio of the Total Labor Force (in %) of Norway in 2005 to that in 2006?
Provide a succinct answer. 0.99. What is the ratio of the Total Labor Force (in %) of Uganda in 2005 to that in 2006?
Your response must be concise. 1.01. What is the ratio of the Total Labor Force (in %) of Europe(all income levels) in 2005 to that in 2007?
Give a very brief answer. 0.99. What is the ratio of the Total Labor Force (in %) in Norway in 2005 to that in 2007?
Your answer should be very brief. 0.95. What is the ratio of the Total Labor Force (in %) of Uganda in 2005 to that in 2007?
Provide a short and direct response. 1.01. What is the ratio of the Total Labor Force (in %) of Europe(all income levels) in 2005 to that in 2008?
Offer a terse response. 0.98. What is the ratio of the Total Labor Force (in %) in Norway in 2005 to that in 2008?
Your answer should be very brief. 0.92. What is the ratio of the Total Labor Force (in %) of Uganda in 2005 to that in 2008?
Make the answer very short. 1.02. What is the ratio of the Total Labor Force (in %) in Europe(all income levels) in 2005 to that in 2009?
Keep it short and to the point. 0.98. What is the ratio of the Total Labor Force (in %) of Gabon in 2005 to that in 2009?
Provide a succinct answer. 0.99. What is the ratio of the Total Labor Force (in %) in Norway in 2005 to that in 2009?
Provide a short and direct response. 0.97. What is the ratio of the Total Labor Force (in %) of Uganda in 2005 to that in 2009?
Your answer should be compact. 1.02. What is the ratio of the Total Labor Force (in %) of Europe(all income levels) in 2006 to that in 2007?
Keep it short and to the point. 1. What is the ratio of the Total Labor Force (in %) of Gabon in 2006 to that in 2007?
Make the answer very short. 1. What is the ratio of the Total Labor Force (in %) of Norway in 2006 to that in 2007?
Provide a succinct answer. 0.96. What is the ratio of the Total Labor Force (in %) of Europe(all income levels) in 2006 to that in 2008?
Give a very brief answer. 0.99. What is the ratio of the Total Labor Force (in %) of Norway in 2006 to that in 2008?
Ensure brevity in your answer.  0.93. What is the ratio of the Total Labor Force (in %) of Gabon in 2006 to that in 2009?
Your answer should be compact. 1. What is the ratio of the Total Labor Force (in %) of Norway in 2006 to that in 2009?
Your response must be concise. 0.98. What is the ratio of the Total Labor Force (in %) in Uganda in 2006 to that in 2009?
Provide a succinct answer. 1.02. What is the ratio of the Total Labor Force (in %) in Europe(all income levels) in 2007 to that in 2008?
Give a very brief answer. 0.99. What is the ratio of the Total Labor Force (in %) of Norway in 2007 to that in 2008?
Provide a succinct answer. 0.97. What is the ratio of the Total Labor Force (in %) of Europe(all income levels) in 2007 to that in 2009?
Offer a very short reply. 0.99. What is the ratio of the Total Labor Force (in %) of Norway in 2007 to that in 2009?
Provide a succinct answer. 1.02. What is the ratio of the Total Labor Force (in %) in Gabon in 2008 to that in 2009?
Offer a terse response. 1. What is the ratio of the Total Labor Force (in %) in Norway in 2008 to that in 2009?
Your response must be concise. 1.06. What is the ratio of the Total Labor Force (in %) of Uganda in 2008 to that in 2009?
Keep it short and to the point. 1. What is the difference between the highest and the second highest Total Labor Force (in %) in Europe(all income levels)?
Ensure brevity in your answer.  0.05. What is the difference between the highest and the second highest Total Labor Force (in %) of Norway?
Offer a very short reply. 2.1. What is the difference between the highest and the second highest Total Labor Force (in %) in Uganda?
Make the answer very short. 2. What is the difference between the highest and the lowest Total Labor Force (in %) in Europe(all income levels)?
Your answer should be compact. 0.75. What is the difference between the highest and the lowest Total Labor Force (in %) of Gabon?
Give a very brief answer. 1.1. 